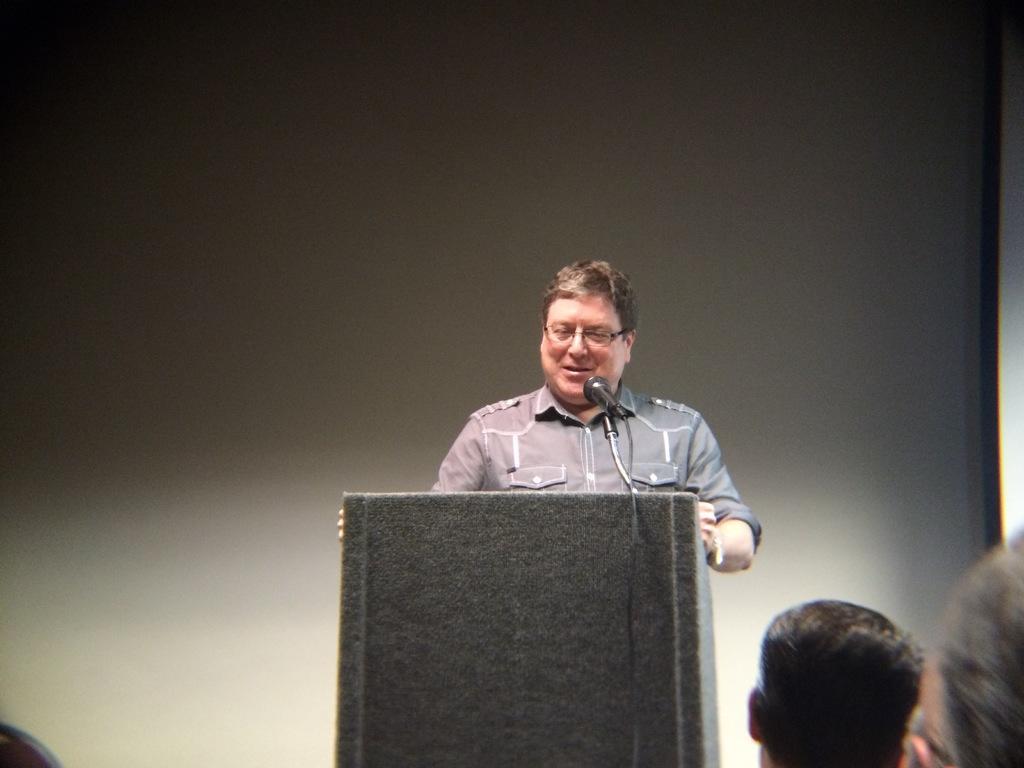Please provide a concise description of this image. In this picture, we can see a few people, among them we can see a person standing, and we can see a podium, microphone, and we can see the background. 